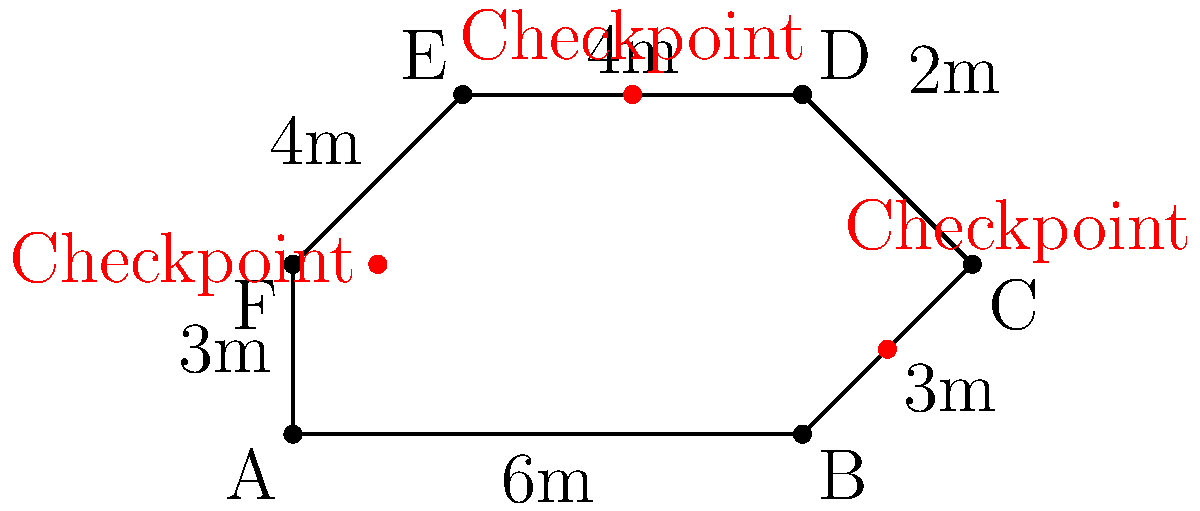A commercial building requires a new outdoor perimeter fence with three security checkpoints. The fence follows the shape of an irregular hexagon as shown in the diagram. Calculate the total length of fencing required for this perimeter security system. Additionally, determine how many meters of fencing are between each pair of consecutive checkpoints, moving clockwise from the leftmost checkpoint. To solve this problem, we'll follow these steps:

1. Calculate the total perimeter of the fence:
   - Sum up all side lengths: $6 + 3 + 2 + 4 + 4 + 3 = 22$ meters

2. Identify the positions of the checkpoints:
   - Leftmost checkpoint: between sides F-A and A-B
   - Bottom-right checkpoint: between sides B-C and C-D
   - Top checkpoint: on side D-E

3. Calculate the distances between checkpoints:
   a) From leftmost to bottom-right checkpoint:
      - Length of A-B + B-C = $6 + 3 = 9$ meters
   b) From bottom-right to top checkpoint:
      - Remaining length of C-D + half of D-E = $2 + 2 = 4$ meters
   c) From top checkpoint to leftmost checkpoint:
      - Half of D-E + full E-F + F-A = $2 + 4 + 3 = 9$ meters

The total perimeter is 22 meters, and the distances between checkpoints (clockwise) are 9 meters, 4 meters, and 9 meters.
Answer: Total fence length: 22m. Distances between checkpoints: 9m, 4m, 9m. 